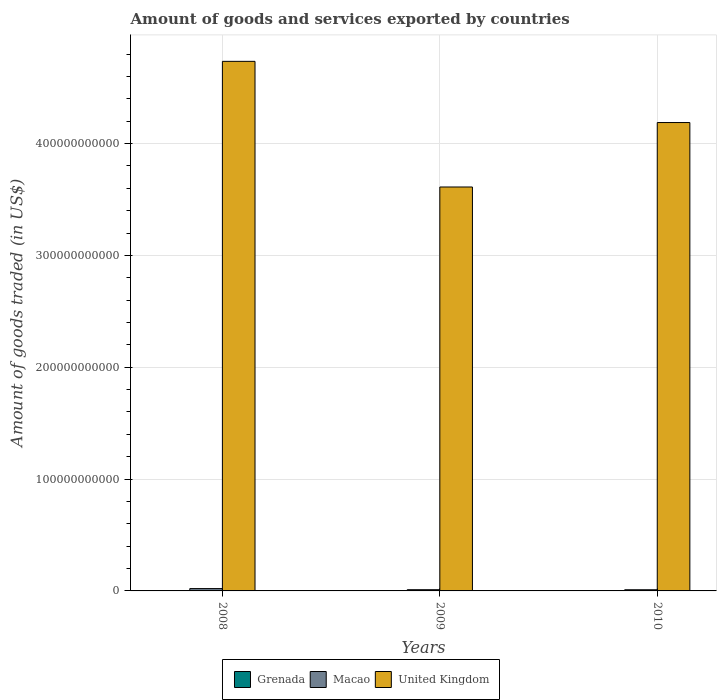Are the number of bars per tick equal to the number of legend labels?
Your answer should be compact. Yes. How many bars are there on the 2nd tick from the left?
Your response must be concise. 3. How many bars are there on the 3rd tick from the right?
Provide a short and direct response. 3. What is the label of the 2nd group of bars from the left?
Ensure brevity in your answer.  2009. What is the total amount of goods and services exported in Macao in 2010?
Offer a terse response. 1.04e+09. Across all years, what is the maximum total amount of goods and services exported in United Kingdom?
Give a very brief answer. 4.73e+11. Across all years, what is the minimum total amount of goods and services exported in United Kingdom?
Your answer should be compact. 3.61e+11. In which year was the total amount of goods and services exported in Grenada maximum?
Give a very brief answer. 2008. In which year was the total amount of goods and services exported in United Kingdom minimum?
Your answer should be compact. 2009. What is the total total amount of goods and services exported in Grenada in the graph?
Offer a very short reply. 1.07e+08. What is the difference between the total amount of goods and services exported in Macao in 2008 and that in 2009?
Give a very brief answer. 1.01e+09. What is the difference between the total amount of goods and services exported in Grenada in 2008 and the total amount of goods and services exported in United Kingdom in 2009?
Your answer should be very brief. -3.61e+11. What is the average total amount of goods and services exported in United Kingdom per year?
Ensure brevity in your answer.  4.18e+11. In the year 2009, what is the difference between the total amount of goods and services exported in Grenada and total amount of goods and services exported in United Kingdom?
Provide a short and direct response. -3.61e+11. What is the ratio of the total amount of goods and services exported in Grenada in 2008 to that in 2009?
Give a very brief answer. 1.15. Is the total amount of goods and services exported in Grenada in 2009 less than that in 2010?
Ensure brevity in your answer.  No. What is the difference between the highest and the second highest total amount of goods and services exported in Grenada?
Ensure brevity in your answer.  5.17e+06. What is the difference between the highest and the lowest total amount of goods and services exported in United Kingdom?
Your answer should be compact. 1.12e+11. In how many years, is the total amount of goods and services exported in Grenada greater than the average total amount of goods and services exported in Grenada taken over all years?
Provide a short and direct response. 1. What does the 3rd bar from the left in 2008 represents?
Your answer should be very brief. United Kingdom. What does the 1st bar from the right in 2009 represents?
Give a very brief answer. United Kingdom. How many bars are there?
Your answer should be compact. 9. Are all the bars in the graph horizontal?
Provide a short and direct response. No. How many years are there in the graph?
Your answer should be compact. 3. What is the difference between two consecutive major ticks on the Y-axis?
Keep it short and to the point. 1.00e+11. Where does the legend appear in the graph?
Provide a short and direct response. Bottom center. How many legend labels are there?
Keep it short and to the point. 3. How are the legend labels stacked?
Your answer should be very brief. Horizontal. What is the title of the graph?
Your response must be concise. Amount of goods and services exported by countries. What is the label or title of the Y-axis?
Your response must be concise. Amount of goods traded (in US$). What is the Amount of goods traded (in US$) of Grenada in 2008?
Offer a terse response. 4.05e+07. What is the Amount of goods traded (in US$) of Macao in 2008?
Provide a short and direct response. 2.09e+09. What is the Amount of goods traded (in US$) in United Kingdom in 2008?
Provide a short and direct response. 4.73e+11. What is the Amount of goods traded (in US$) of Grenada in 2009?
Offer a terse response. 3.53e+07. What is the Amount of goods traded (in US$) of Macao in 2009?
Keep it short and to the point. 1.09e+09. What is the Amount of goods traded (in US$) in United Kingdom in 2009?
Your answer should be compact. 3.61e+11. What is the Amount of goods traded (in US$) in Grenada in 2010?
Offer a terse response. 3.11e+07. What is the Amount of goods traded (in US$) of Macao in 2010?
Give a very brief answer. 1.04e+09. What is the Amount of goods traded (in US$) of United Kingdom in 2010?
Offer a very short reply. 4.19e+11. Across all years, what is the maximum Amount of goods traded (in US$) of Grenada?
Keep it short and to the point. 4.05e+07. Across all years, what is the maximum Amount of goods traded (in US$) of Macao?
Keep it short and to the point. 2.09e+09. Across all years, what is the maximum Amount of goods traded (in US$) in United Kingdom?
Offer a terse response. 4.73e+11. Across all years, what is the minimum Amount of goods traded (in US$) of Grenada?
Keep it short and to the point. 3.11e+07. Across all years, what is the minimum Amount of goods traded (in US$) of Macao?
Your answer should be compact. 1.04e+09. Across all years, what is the minimum Amount of goods traded (in US$) of United Kingdom?
Provide a short and direct response. 3.61e+11. What is the total Amount of goods traded (in US$) of Grenada in the graph?
Provide a short and direct response. 1.07e+08. What is the total Amount of goods traded (in US$) of Macao in the graph?
Your answer should be very brief. 4.22e+09. What is the total Amount of goods traded (in US$) of United Kingdom in the graph?
Give a very brief answer. 1.25e+12. What is the difference between the Amount of goods traded (in US$) in Grenada in 2008 and that in 2009?
Give a very brief answer. 5.17e+06. What is the difference between the Amount of goods traded (in US$) in Macao in 2008 and that in 2009?
Ensure brevity in your answer.  1.01e+09. What is the difference between the Amount of goods traded (in US$) in United Kingdom in 2008 and that in 2009?
Offer a terse response. 1.12e+11. What is the difference between the Amount of goods traded (in US$) of Grenada in 2008 and that in 2010?
Provide a succinct answer. 9.34e+06. What is the difference between the Amount of goods traded (in US$) in Macao in 2008 and that in 2010?
Offer a very short reply. 1.05e+09. What is the difference between the Amount of goods traded (in US$) in United Kingdom in 2008 and that in 2010?
Give a very brief answer. 5.47e+1. What is the difference between the Amount of goods traded (in US$) of Grenada in 2009 and that in 2010?
Provide a succinct answer. 4.17e+06. What is the difference between the Amount of goods traded (in US$) of Macao in 2009 and that in 2010?
Provide a short and direct response. 4.60e+07. What is the difference between the Amount of goods traded (in US$) of United Kingdom in 2009 and that in 2010?
Your answer should be very brief. -5.76e+1. What is the difference between the Amount of goods traded (in US$) in Grenada in 2008 and the Amount of goods traded (in US$) in Macao in 2009?
Give a very brief answer. -1.05e+09. What is the difference between the Amount of goods traded (in US$) of Grenada in 2008 and the Amount of goods traded (in US$) of United Kingdom in 2009?
Provide a succinct answer. -3.61e+11. What is the difference between the Amount of goods traded (in US$) of Macao in 2008 and the Amount of goods traded (in US$) of United Kingdom in 2009?
Offer a very short reply. -3.59e+11. What is the difference between the Amount of goods traded (in US$) of Grenada in 2008 and the Amount of goods traded (in US$) of Macao in 2010?
Your answer should be compact. -1.00e+09. What is the difference between the Amount of goods traded (in US$) of Grenada in 2008 and the Amount of goods traded (in US$) of United Kingdom in 2010?
Your response must be concise. -4.19e+11. What is the difference between the Amount of goods traded (in US$) in Macao in 2008 and the Amount of goods traded (in US$) in United Kingdom in 2010?
Your response must be concise. -4.17e+11. What is the difference between the Amount of goods traded (in US$) of Grenada in 2009 and the Amount of goods traded (in US$) of Macao in 2010?
Offer a terse response. -1.00e+09. What is the difference between the Amount of goods traded (in US$) of Grenada in 2009 and the Amount of goods traded (in US$) of United Kingdom in 2010?
Offer a very short reply. -4.19e+11. What is the difference between the Amount of goods traded (in US$) in Macao in 2009 and the Amount of goods traded (in US$) in United Kingdom in 2010?
Provide a succinct answer. -4.18e+11. What is the average Amount of goods traded (in US$) of Grenada per year?
Your answer should be compact. 3.56e+07. What is the average Amount of goods traded (in US$) of Macao per year?
Offer a very short reply. 1.41e+09. What is the average Amount of goods traded (in US$) in United Kingdom per year?
Give a very brief answer. 4.18e+11. In the year 2008, what is the difference between the Amount of goods traded (in US$) of Grenada and Amount of goods traded (in US$) of Macao?
Offer a very short reply. -2.05e+09. In the year 2008, what is the difference between the Amount of goods traded (in US$) of Grenada and Amount of goods traded (in US$) of United Kingdom?
Keep it short and to the point. -4.73e+11. In the year 2008, what is the difference between the Amount of goods traded (in US$) of Macao and Amount of goods traded (in US$) of United Kingdom?
Your answer should be compact. -4.71e+11. In the year 2009, what is the difference between the Amount of goods traded (in US$) of Grenada and Amount of goods traded (in US$) of Macao?
Ensure brevity in your answer.  -1.05e+09. In the year 2009, what is the difference between the Amount of goods traded (in US$) in Grenada and Amount of goods traded (in US$) in United Kingdom?
Your response must be concise. -3.61e+11. In the year 2009, what is the difference between the Amount of goods traded (in US$) in Macao and Amount of goods traded (in US$) in United Kingdom?
Give a very brief answer. -3.60e+11. In the year 2010, what is the difference between the Amount of goods traded (in US$) of Grenada and Amount of goods traded (in US$) of Macao?
Offer a terse response. -1.01e+09. In the year 2010, what is the difference between the Amount of goods traded (in US$) in Grenada and Amount of goods traded (in US$) in United Kingdom?
Give a very brief answer. -4.19e+11. In the year 2010, what is the difference between the Amount of goods traded (in US$) in Macao and Amount of goods traded (in US$) in United Kingdom?
Offer a very short reply. -4.18e+11. What is the ratio of the Amount of goods traded (in US$) in Grenada in 2008 to that in 2009?
Give a very brief answer. 1.15. What is the ratio of the Amount of goods traded (in US$) of Macao in 2008 to that in 2009?
Your answer should be very brief. 1.93. What is the ratio of the Amount of goods traded (in US$) in United Kingdom in 2008 to that in 2009?
Offer a very short reply. 1.31. What is the ratio of the Amount of goods traded (in US$) of Grenada in 2008 to that in 2010?
Provide a succinct answer. 1.3. What is the ratio of the Amount of goods traded (in US$) of Macao in 2008 to that in 2010?
Ensure brevity in your answer.  2.01. What is the ratio of the Amount of goods traded (in US$) in United Kingdom in 2008 to that in 2010?
Your answer should be compact. 1.13. What is the ratio of the Amount of goods traded (in US$) of Grenada in 2009 to that in 2010?
Offer a very short reply. 1.13. What is the ratio of the Amount of goods traded (in US$) in Macao in 2009 to that in 2010?
Offer a terse response. 1.04. What is the ratio of the Amount of goods traded (in US$) of United Kingdom in 2009 to that in 2010?
Your answer should be very brief. 0.86. What is the difference between the highest and the second highest Amount of goods traded (in US$) in Grenada?
Provide a succinct answer. 5.17e+06. What is the difference between the highest and the second highest Amount of goods traded (in US$) of Macao?
Keep it short and to the point. 1.01e+09. What is the difference between the highest and the second highest Amount of goods traded (in US$) in United Kingdom?
Ensure brevity in your answer.  5.47e+1. What is the difference between the highest and the lowest Amount of goods traded (in US$) in Grenada?
Provide a succinct answer. 9.34e+06. What is the difference between the highest and the lowest Amount of goods traded (in US$) in Macao?
Provide a succinct answer. 1.05e+09. What is the difference between the highest and the lowest Amount of goods traded (in US$) in United Kingdom?
Provide a succinct answer. 1.12e+11. 